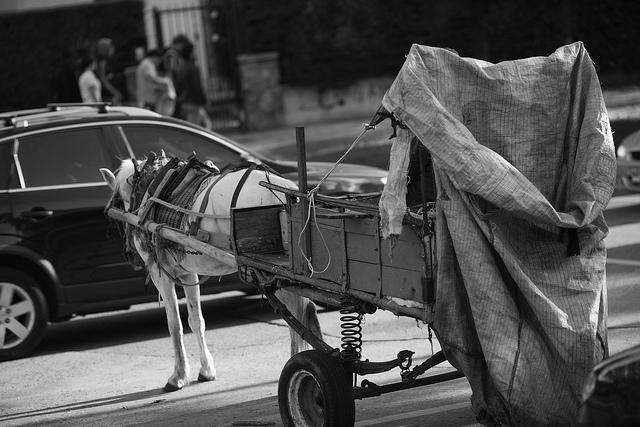Is this a miniature horse?
Quick response, please. No. Are there suspension springs on the wagon?
Quick response, please. Yes. Is this picture in color?
Concise answer only. No. Does this vehicle travel by air or by water?
Give a very brief answer. Ground. 